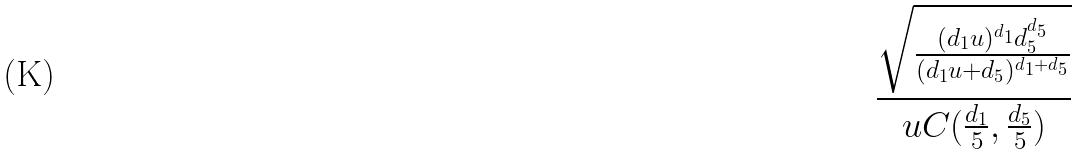<formula> <loc_0><loc_0><loc_500><loc_500>\frac { \sqrt { \frac { ( d _ { 1 } u ) ^ { d _ { 1 } } d _ { 5 } ^ { d _ { 5 } } } { ( d _ { 1 } u + d _ { 5 } ) ^ { d _ { 1 } + d _ { 5 } } } } } { u C ( \frac { d _ { 1 } } { 5 } , \frac { d _ { 5 } } { 5 } ) }</formula> 